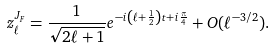<formula> <loc_0><loc_0><loc_500><loc_500>z ^ { J _ { F } } _ { \ell } = \frac { 1 } { \sqrt { 2 \ell + 1 } } e ^ { - i \left ( \ell + \frac { 1 } { 2 } \right ) t + i \frac { \pi } { 4 } } + O ( \ell ^ { - 3 / 2 } ) .</formula> 